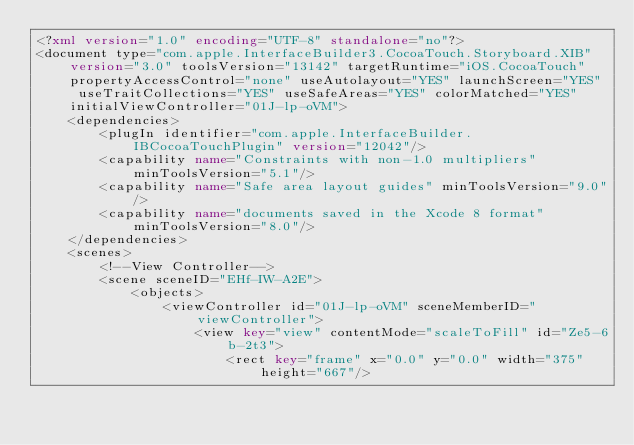Convert code to text. <code><loc_0><loc_0><loc_500><loc_500><_XML_><?xml version="1.0" encoding="UTF-8" standalone="no"?>
<document type="com.apple.InterfaceBuilder3.CocoaTouch.Storyboard.XIB" version="3.0" toolsVersion="13142" targetRuntime="iOS.CocoaTouch" propertyAccessControl="none" useAutolayout="YES" launchScreen="YES" useTraitCollections="YES" useSafeAreas="YES" colorMatched="YES" initialViewController="01J-lp-oVM">
    <dependencies>
        <plugIn identifier="com.apple.InterfaceBuilder.IBCocoaTouchPlugin" version="12042"/>
        <capability name="Constraints with non-1.0 multipliers" minToolsVersion="5.1"/>
        <capability name="Safe area layout guides" minToolsVersion="9.0"/>
        <capability name="documents saved in the Xcode 8 format" minToolsVersion="8.0"/>
    </dependencies>
    <scenes>
        <!--View Controller-->
        <scene sceneID="EHf-IW-A2E">
            <objects>
                <viewController id="01J-lp-oVM" sceneMemberID="viewController">
                    <view key="view" contentMode="scaleToFill" id="Ze5-6b-2t3">
                        <rect key="frame" x="0.0" y="0.0" width="375" height="667"/></code> 